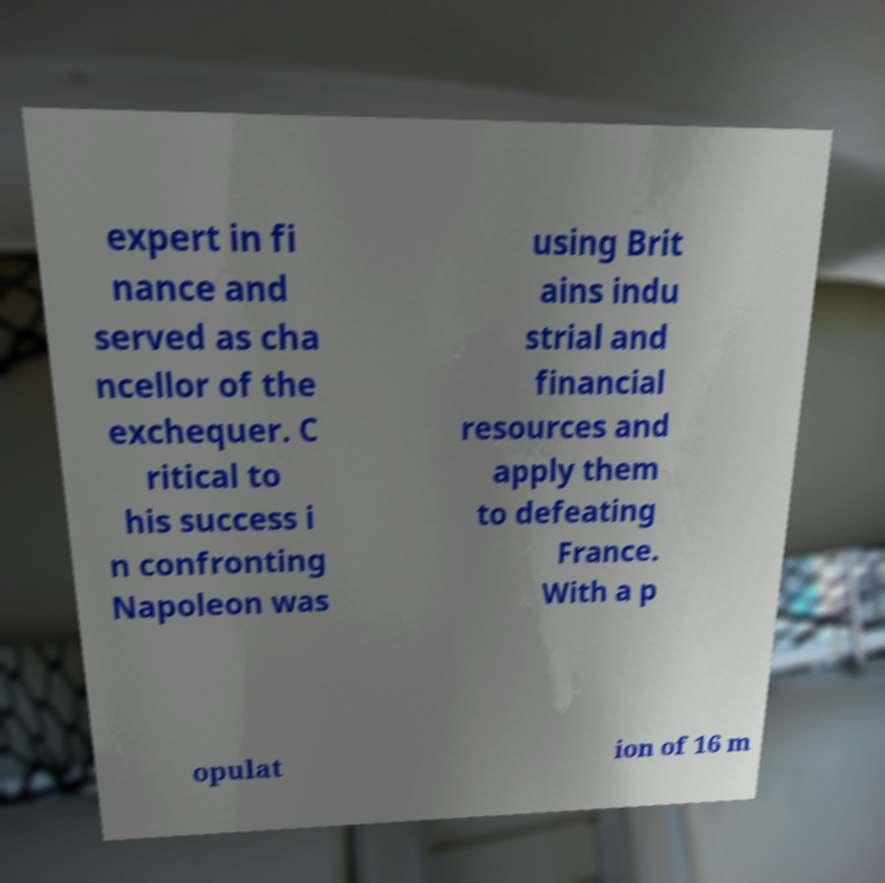Can you accurately transcribe the text from the provided image for me? expert in fi nance and served as cha ncellor of the exchequer. C ritical to his success i n confronting Napoleon was using Brit ains indu strial and financial resources and apply them to defeating France. With a p opulat ion of 16 m 